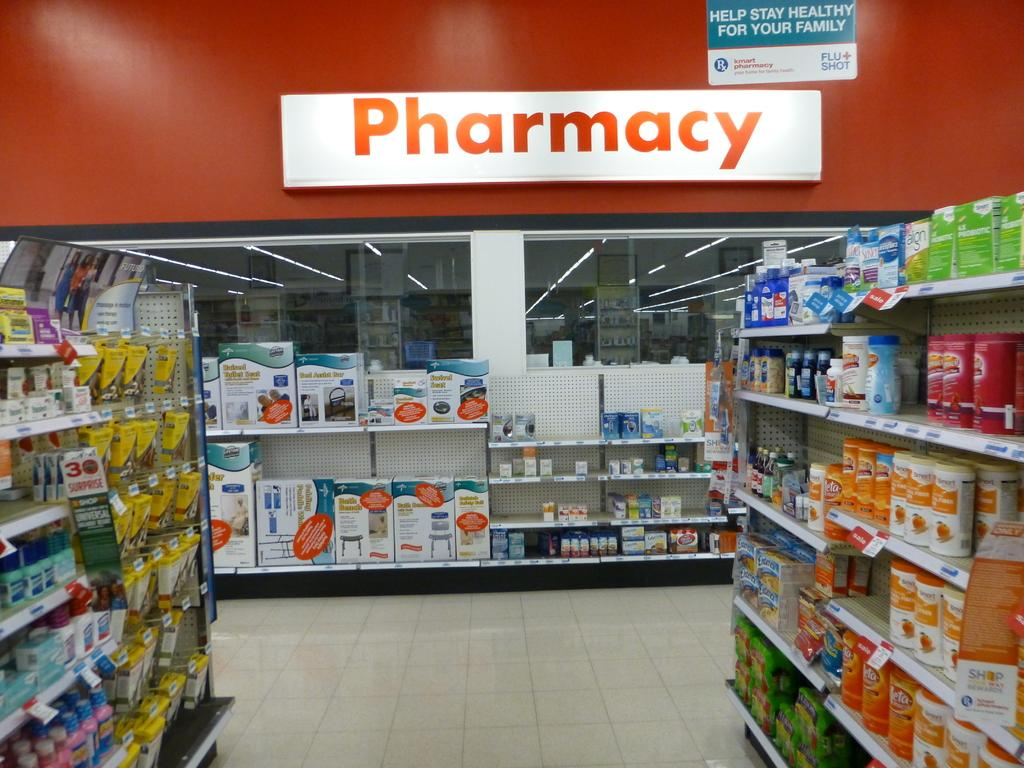Provide a one-sentence caption for the provided image. medicine isle of store with pharmacy in the back and sign overhead that states help stay healthy for your family. 